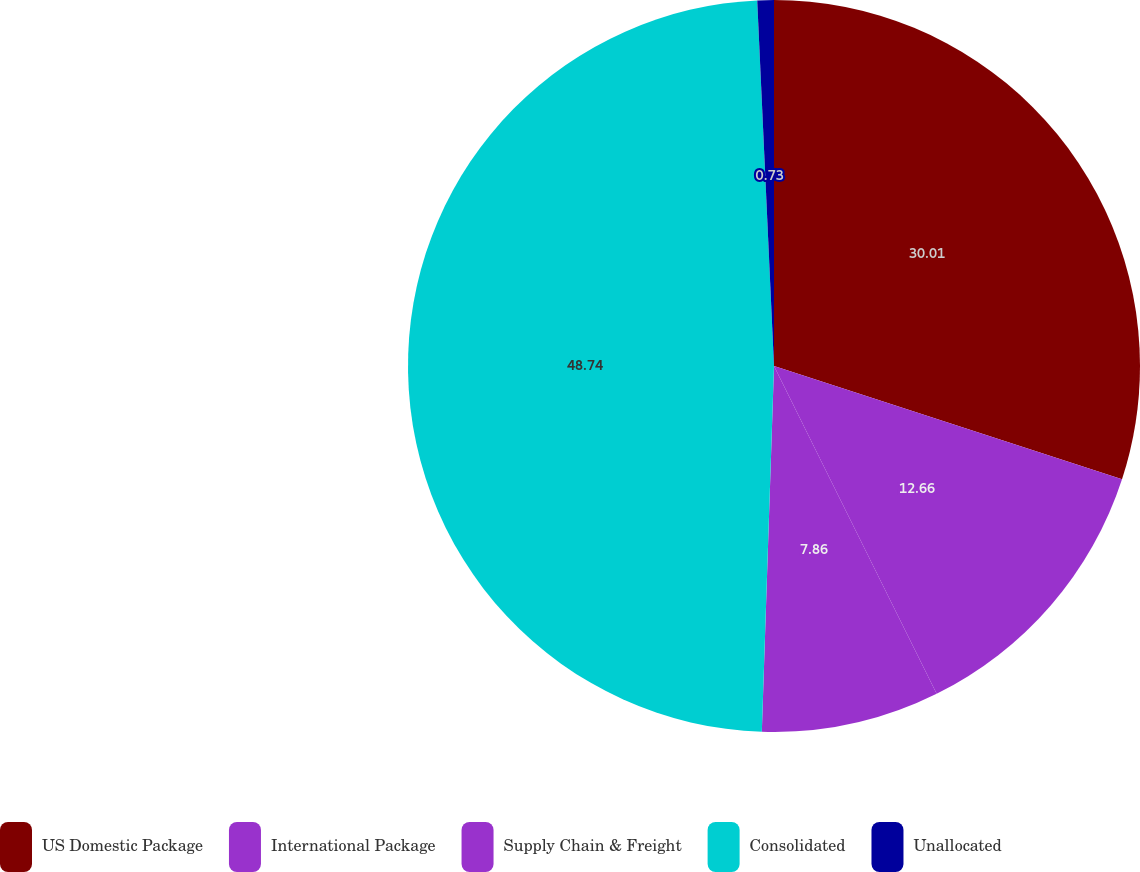Convert chart. <chart><loc_0><loc_0><loc_500><loc_500><pie_chart><fcel>US Domestic Package<fcel>International Package<fcel>Supply Chain & Freight<fcel>Consolidated<fcel>Unallocated<nl><fcel>30.01%<fcel>12.66%<fcel>7.86%<fcel>48.74%<fcel>0.73%<nl></chart> 